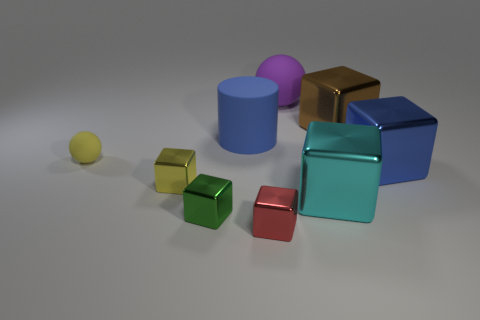What colors are present in the objects shown? The image showcases objects with a variety of colors, including blue, purple, pink, red, yellow, green, and a shade of metallic gold. 